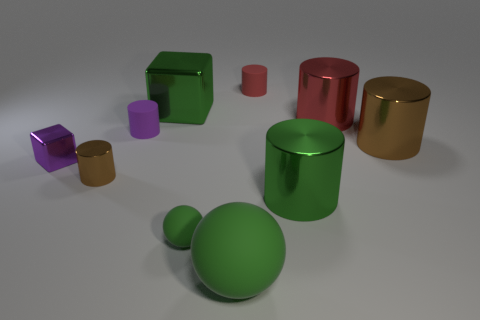There is a big matte object that is the same color as the big block; what is its shape?
Your answer should be compact. Sphere. What is the size of the metallic cylinder that is the same color as the big metallic cube?
Make the answer very short. Large. Do the tiny sphere and the large block have the same color?
Offer a very short reply. Yes. What is the shape of the metallic object in front of the brown thing on the left side of the large green rubber thing?
Provide a succinct answer. Cylinder. Is the number of small brown cylinders less than the number of tiny things?
Ensure brevity in your answer.  Yes. What size is the metallic object that is both behind the tiny purple matte cylinder and right of the big rubber thing?
Keep it short and to the point. Large. Do the purple cylinder and the green metal block have the same size?
Your answer should be compact. No. There is a big shiny object to the left of the tiny red matte thing; is it the same color as the small metal block?
Give a very brief answer. No. What number of small purple objects are in front of the tiny green object?
Provide a short and direct response. 0. Is the number of big cyan things greater than the number of tiny purple rubber cylinders?
Offer a terse response. No. 